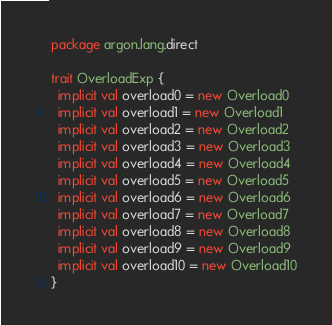<code> <loc_0><loc_0><loc_500><loc_500><_Scala_>package argon.lang.direct

trait OverloadExp {
  implicit val overload0 = new Overload0
  implicit val overload1 = new Overload1
  implicit val overload2 = new Overload2
  implicit val overload3 = new Overload3
  implicit val overload4 = new Overload4
  implicit val overload5 = new Overload5
  implicit val overload6 = new Overload6
  implicit val overload7 = new Overload7
  implicit val overload8 = new Overload8
  implicit val overload9 = new Overload9
  implicit val overload10 = new Overload10
}
</code> 